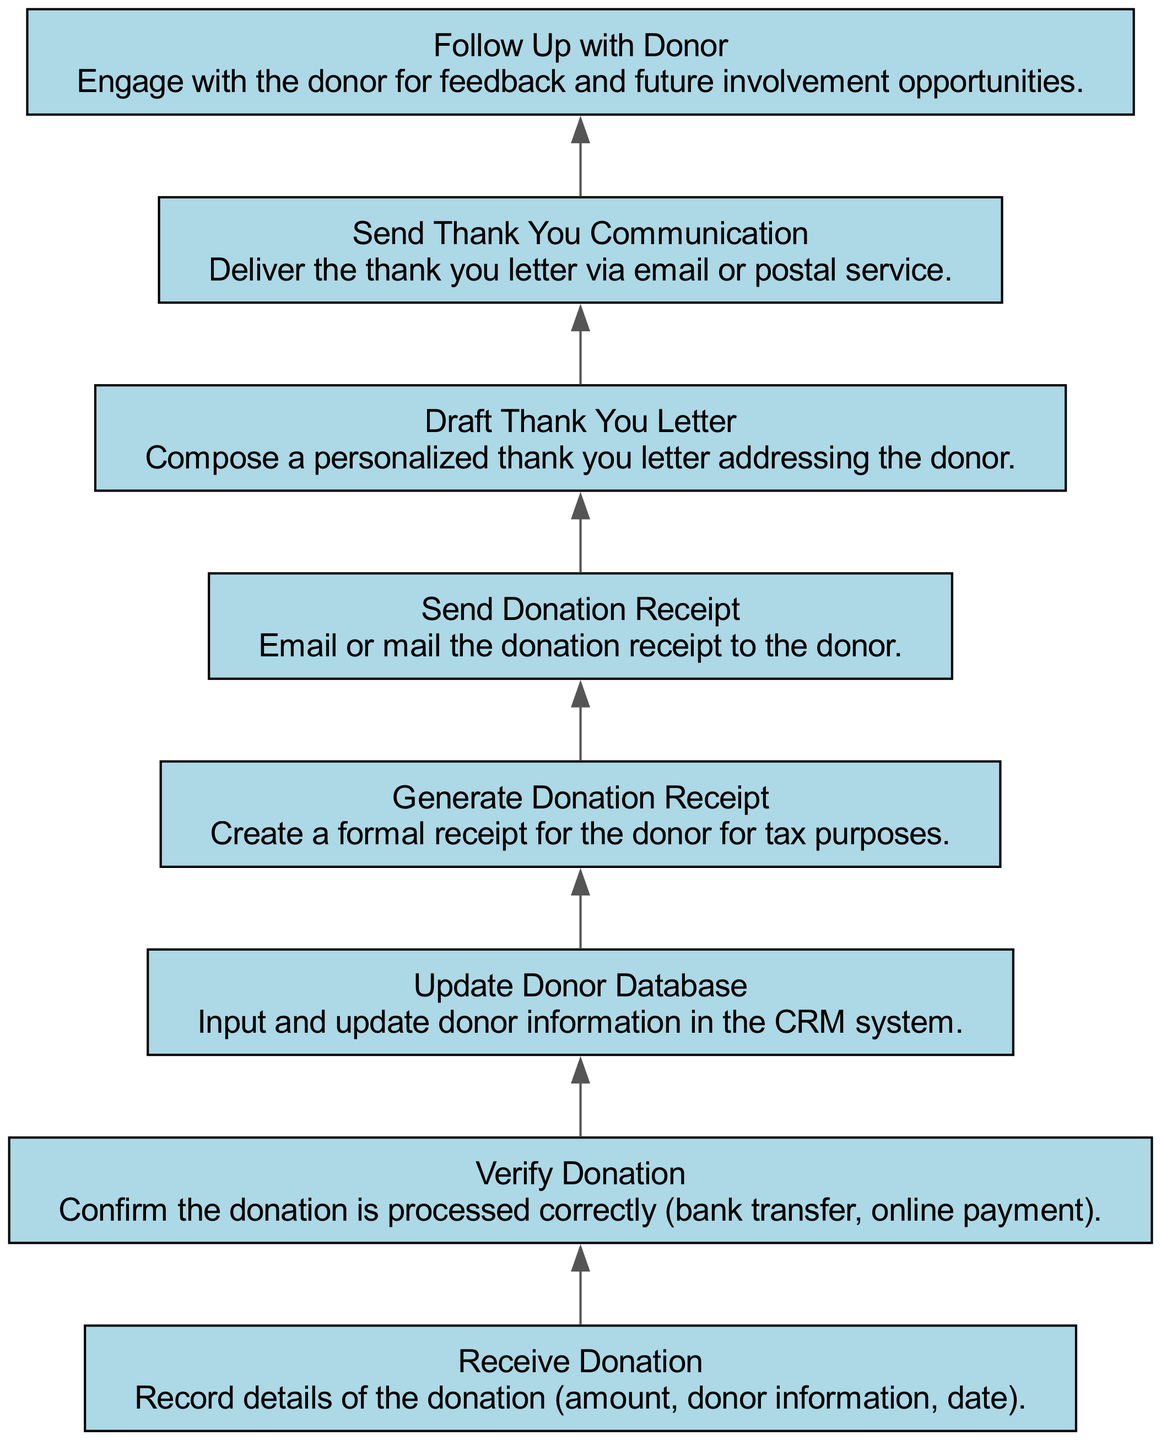What is the first step in the donor acknowledgment process? The diagram indicates that the first step is "Receive Donation," where the organization records details about the donation.
Answer: Receive Donation How many total steps are detailed in this diagram? By counting each of the nodes in the flow chart, there are a total of 8 steps present in the donor acknowledgment process.
Answer: 8 What happens immediately after "Verify Donation"? According to the diagram, the next step that follows "Verify Donation" is "Update Donor Database."
Answer: Update Donor Database What is prepared before the Thank You Communication is sent? The diagram shows that before sending the Thank You Communication, the "Draft Thank You Letter" step is prepared.
Answer: Draft Thank You Letter After generating the donation receipt, what is the next action taken? The diagram outlines that after "Generate Donation Receipt," the subsequent step is "Send Donation Receipt."
Answer: Send Donation Receipt Which step in the process requires engaging with the donor for feedback? The last step described in the diagram, "Follow Up with Donor," specifically involves engaging with the donor for feedback and future involvement opportunities.
Answer: Follow Up with Donor What is the relationship between "Send Donation Receipt" and "Draft Thank You Letter"? The flowchart shows that "Send Donation Receipt" occurs before "Draft Thank You Letter," indicating a sequential relationship between these two steps in the process.
Answer: Sequential relationship Is "Update Donor Database" related to any previous steps? Yes, "Update Donor Database" follows directly after "Verify Donation," meaning it is related to that step in the process flow.
Answer: Yes 